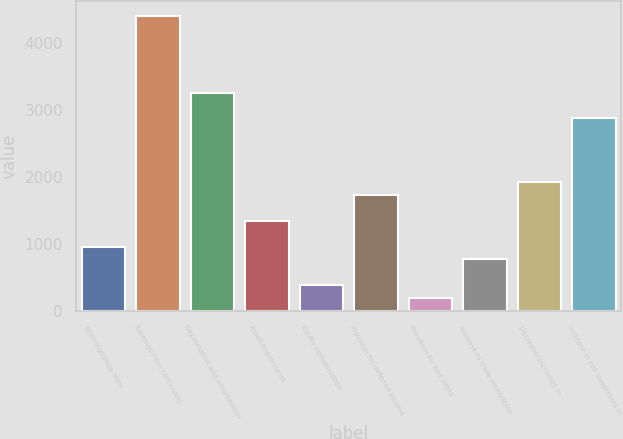Convert chart to OTSL. <chart><loc_0><loc_0><loc_500><loc_500><bar_chart><fcel>(Earnings)/loss from<fcel>Earnings from continuing<fcel>Depreciation and amortization<fcel>Asset impairments<fcel>Equity compensation<fcel>Provision for deferred income<fcel>Provision for bad debts<fcel>Increase in trade receivables<fcel>Decrease/(increase) in<fcel>Increase in net investment in<nl><fcel>963.4<fcel>4415.08<fcel>3264.52<fcel>1346.92<fcel>388.12<fcel>1730.44<fcel>196.36<fcel>771.64<fcel>1922.2<fcel>2881<nl></chart> 